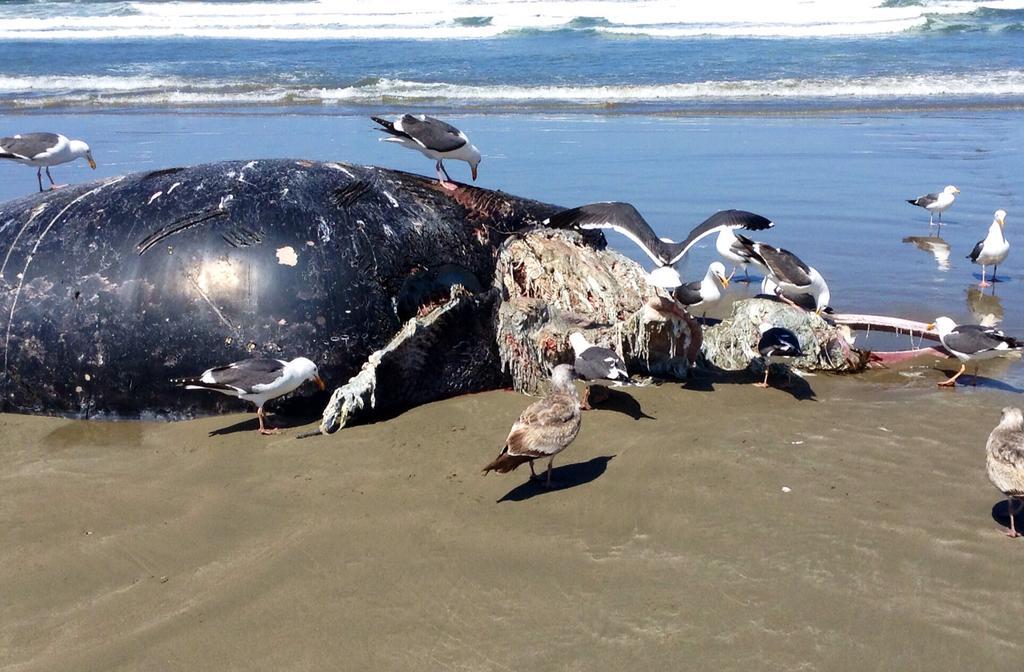Describe this image in one or two sentences. In this image we can see the dead animal, and few birds on the ground. And there are two birds on the water. In the background, we can see the water. 